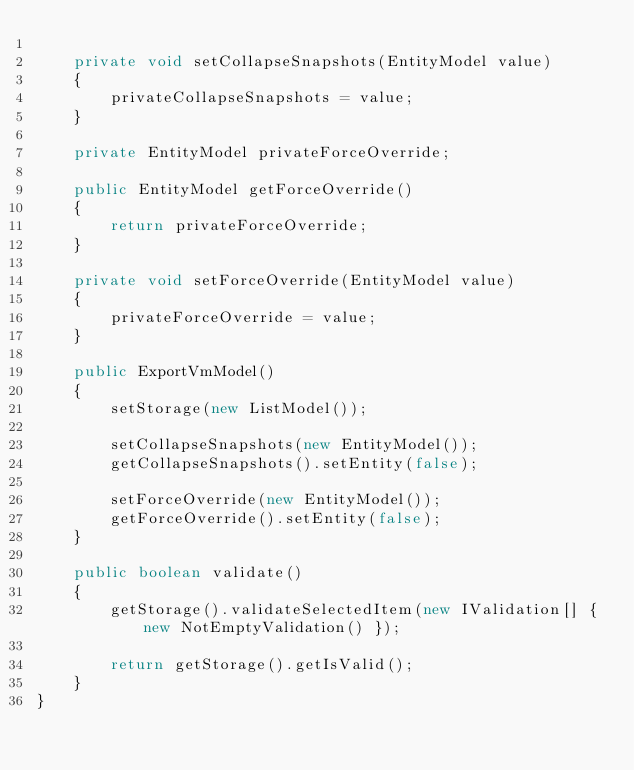Convert code to text. <code><loc_0><loc_0><loc_500><loc_500><_Java_>
    private void setCollapseSnapshots(EntityModel value)
    {
        privateCollapseSnapshots = value;
    }

    private EntityModel privateForceOverride;

    public EntityModel getForceOverride()
    {
        return privateForceOverride;
    }

    private void setForceOverride(EntityModel value)
    {
        privateForceOverride = value;
    }

    public ExportVmModel()
    {
        setStorage(new ListModel());

        setCollapseSnapshots(new EntityModel());
        getCollapseSnapshots().setEntity(false);

        setForceOverride(new EntityModel());
        getForceOverride().setEntity(false);
    }

    public boolean validate()
    {
        getStorage().validateSelectedItem(new IValidation[] { new NotEmptyValidation() });

        return getStorage().getIsValid();
    }
}
</code> 